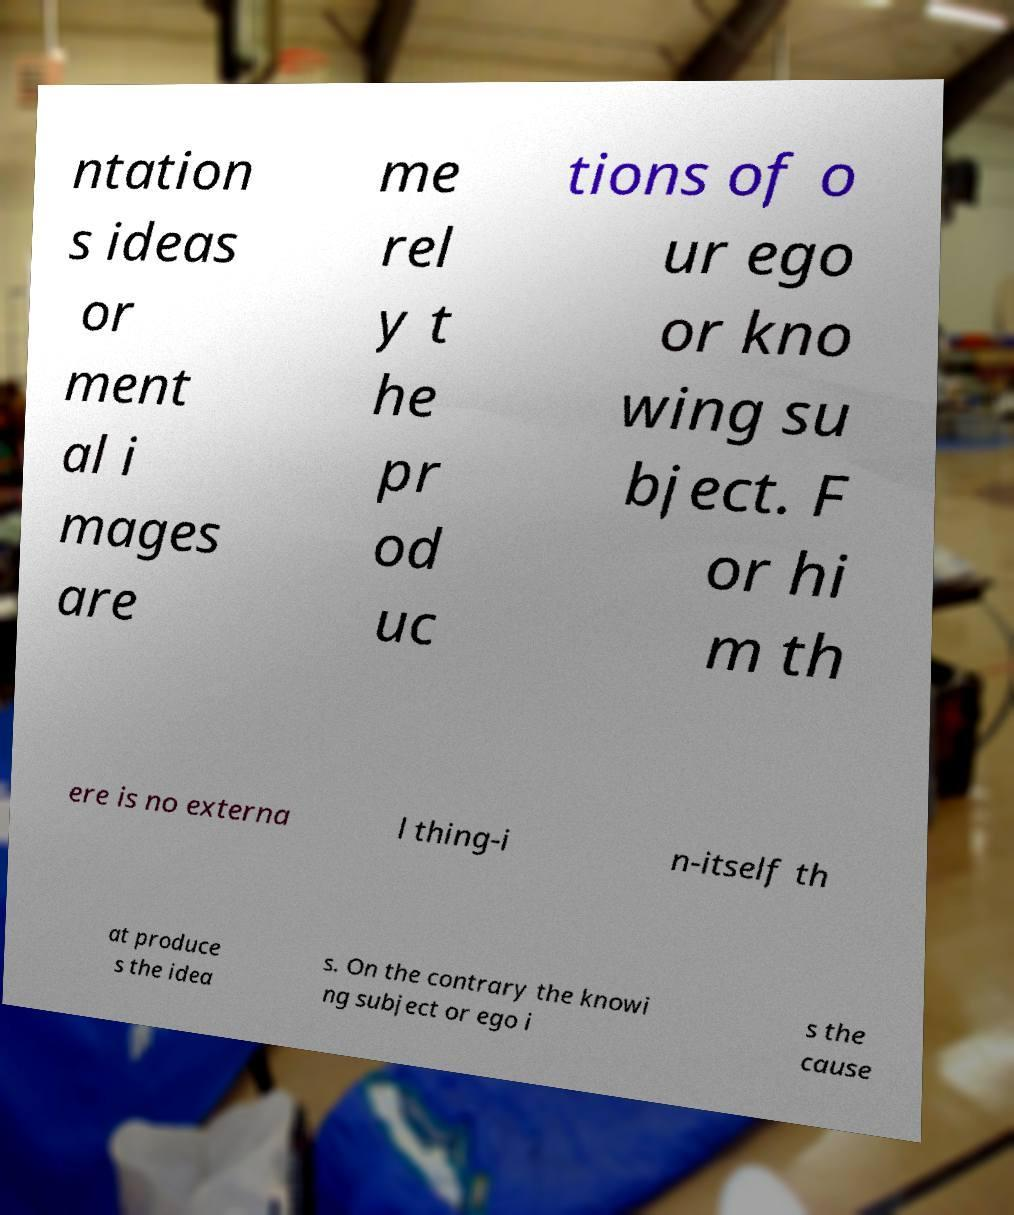Could you extract and type out the text from this image? ntation s ideas or ment al i mages are me rel y t he pr od uc tions of o ur ego or kno wing su bject. F or hi m th ere is no externa l thing-i n-itself th at produce s the idea s. On the contrary the knowi ng subject or ego i s the cause 